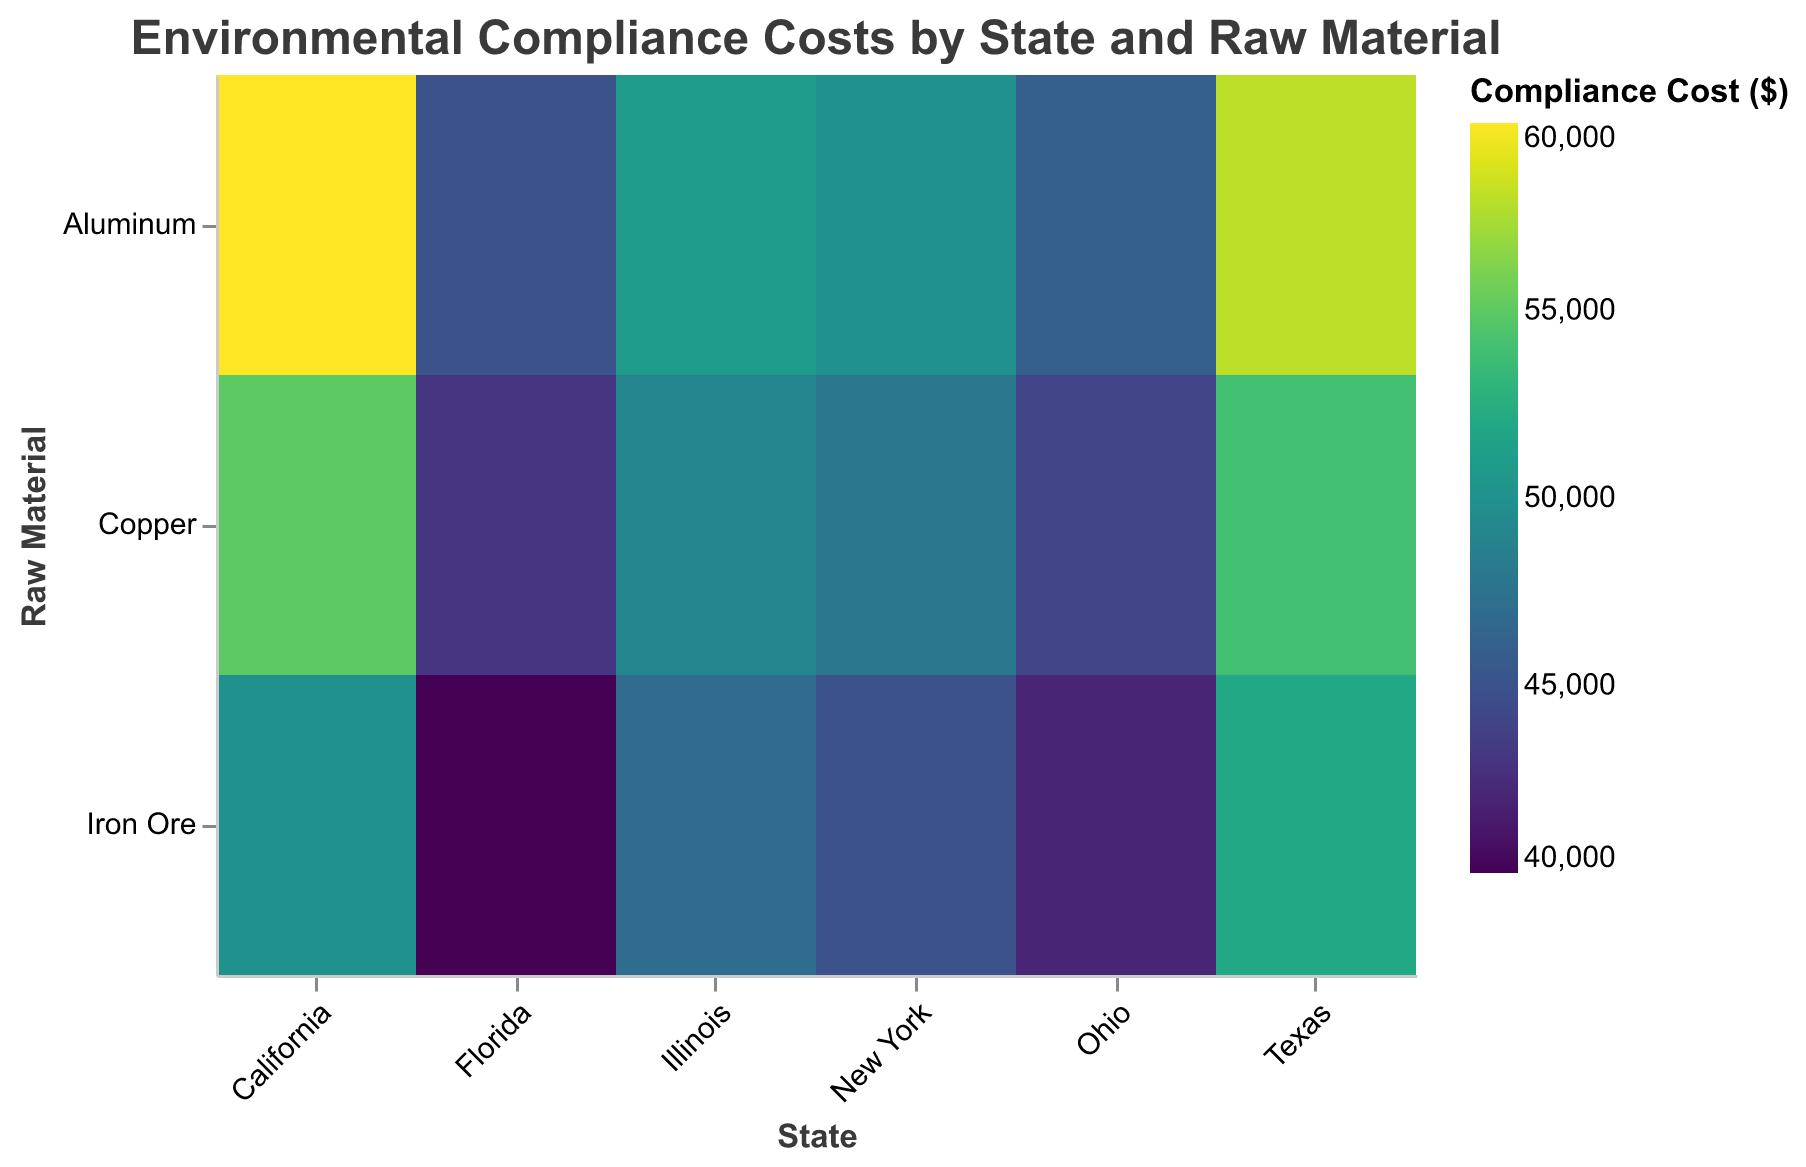What is the highest environmental compliance cost for Aluminum in Texas? Look at the row for Aluminum and the column for Texas. The color corresponding to Texas for Aluminum shows a compliance cost of 58000.
Answer: 58000 Which state has the lowest compliance cost for Iron Ore? Compare the colors of the cells in the Iron Ore row across all states. Florida has the lightest color, indicating the lowest compliance cost of 40000.
Answer: Florida What is the range of compliance costs for Copper across all states? Identify the highest and lowest costs in the Copper row. The highest is 55000 (California), and the lowest is 43000 (Florida). The range is 55000 - 43000 = 12000.
Answer: 12000 Which raw material has the highest compliance cost in California? Compare the colors in the California column. Aluminum has the darkest shade, indicating the highest cost of 60000.
Answer: Aluminum Which state has the most consistent compliance costs across all raw materials? Check the shades of colors within each state's column. Ohio's colors are the most similar, indicating consistent compliance costs of 42000, 46000, and 44000.
Answer: Ohio Calculate the average compliance cost for Illinois. Sum the costs for Iron Ore, Aluminum, and Copper in Illinois (47000 + 51000 + 49000 = 147000) and then divide by 3 (147000 / 3).
Answer: 49000 Which raw material shows the greatest variability in compliance costs across states? Check the shades across each row and compare their range. Aluminum has values ranging from 45000 to 60000, a range of 15000, which is the largest compared to other materials.
Answer: Aluminum What is the difference in compliance cost for Copper between New York and Florida? Look at the Copper row and find the costs for New York and Florida. Subtract the Florida cost from the New York cost (48000 - 43000).
Answer: 5000 How does the environmental compliance cost for Iron Ore in Texas compare to that in Ohio? Compare the colors in the Iron Ore row for Texas and Ohio. Texas has a cost of 52000, while Ohio has 42000, making Texas's cost higher.
Answer: Texas is higher What is the total compliance cost across all raw materials in New York? Sum the compliance costs for Iron Ore, Aluminum, and Copper in New York (45000 + 50000 + 48000).
Answer: 143000 